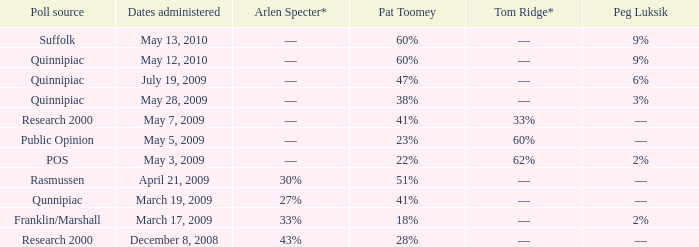In which poll source does arlen specter have a –– rating, while tom ridge has a 60% rating? Public Opinion. 